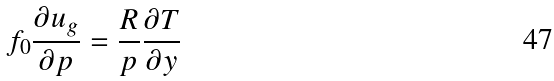<formula> <loc_0><loc_0><loc_500><loc_500>f _ { 0 } \frac { \partial u _ { g } } { \partial p } = \frac { R } { p } \frac { \partial T } { \partial y }</formula> 